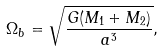<formula> <loc_0><loc_0><loc_500><loc_500>\Omega _ { b } = \sqrt { \frac { G ( M _ { 1 } + M _ { 2 } ) } { a ^ { 3 } } } ,</formula> 